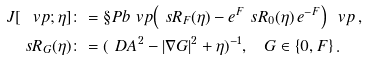Convert formula to latex. <formula><loc_0><loc_0><loc_500><loc_500>J [ \ v p ; \eta ] & \colon = \S P b { \ v p } { \left ( \ s R _ { F } ( \eta ) - e ^ { F } \ s R _ { 0 } ( \eta ) \, e ^ { - F } \right ) \, \ v p } \, , \\ \ s R _ { G } ( \eta ) & \colon = ( \ D A ^ { 2 } - | \nabla G | ^ { 2 } + \eta ) ^ { - 1 } , \quad G \in \{ 0 , F \} \, .</formula> 